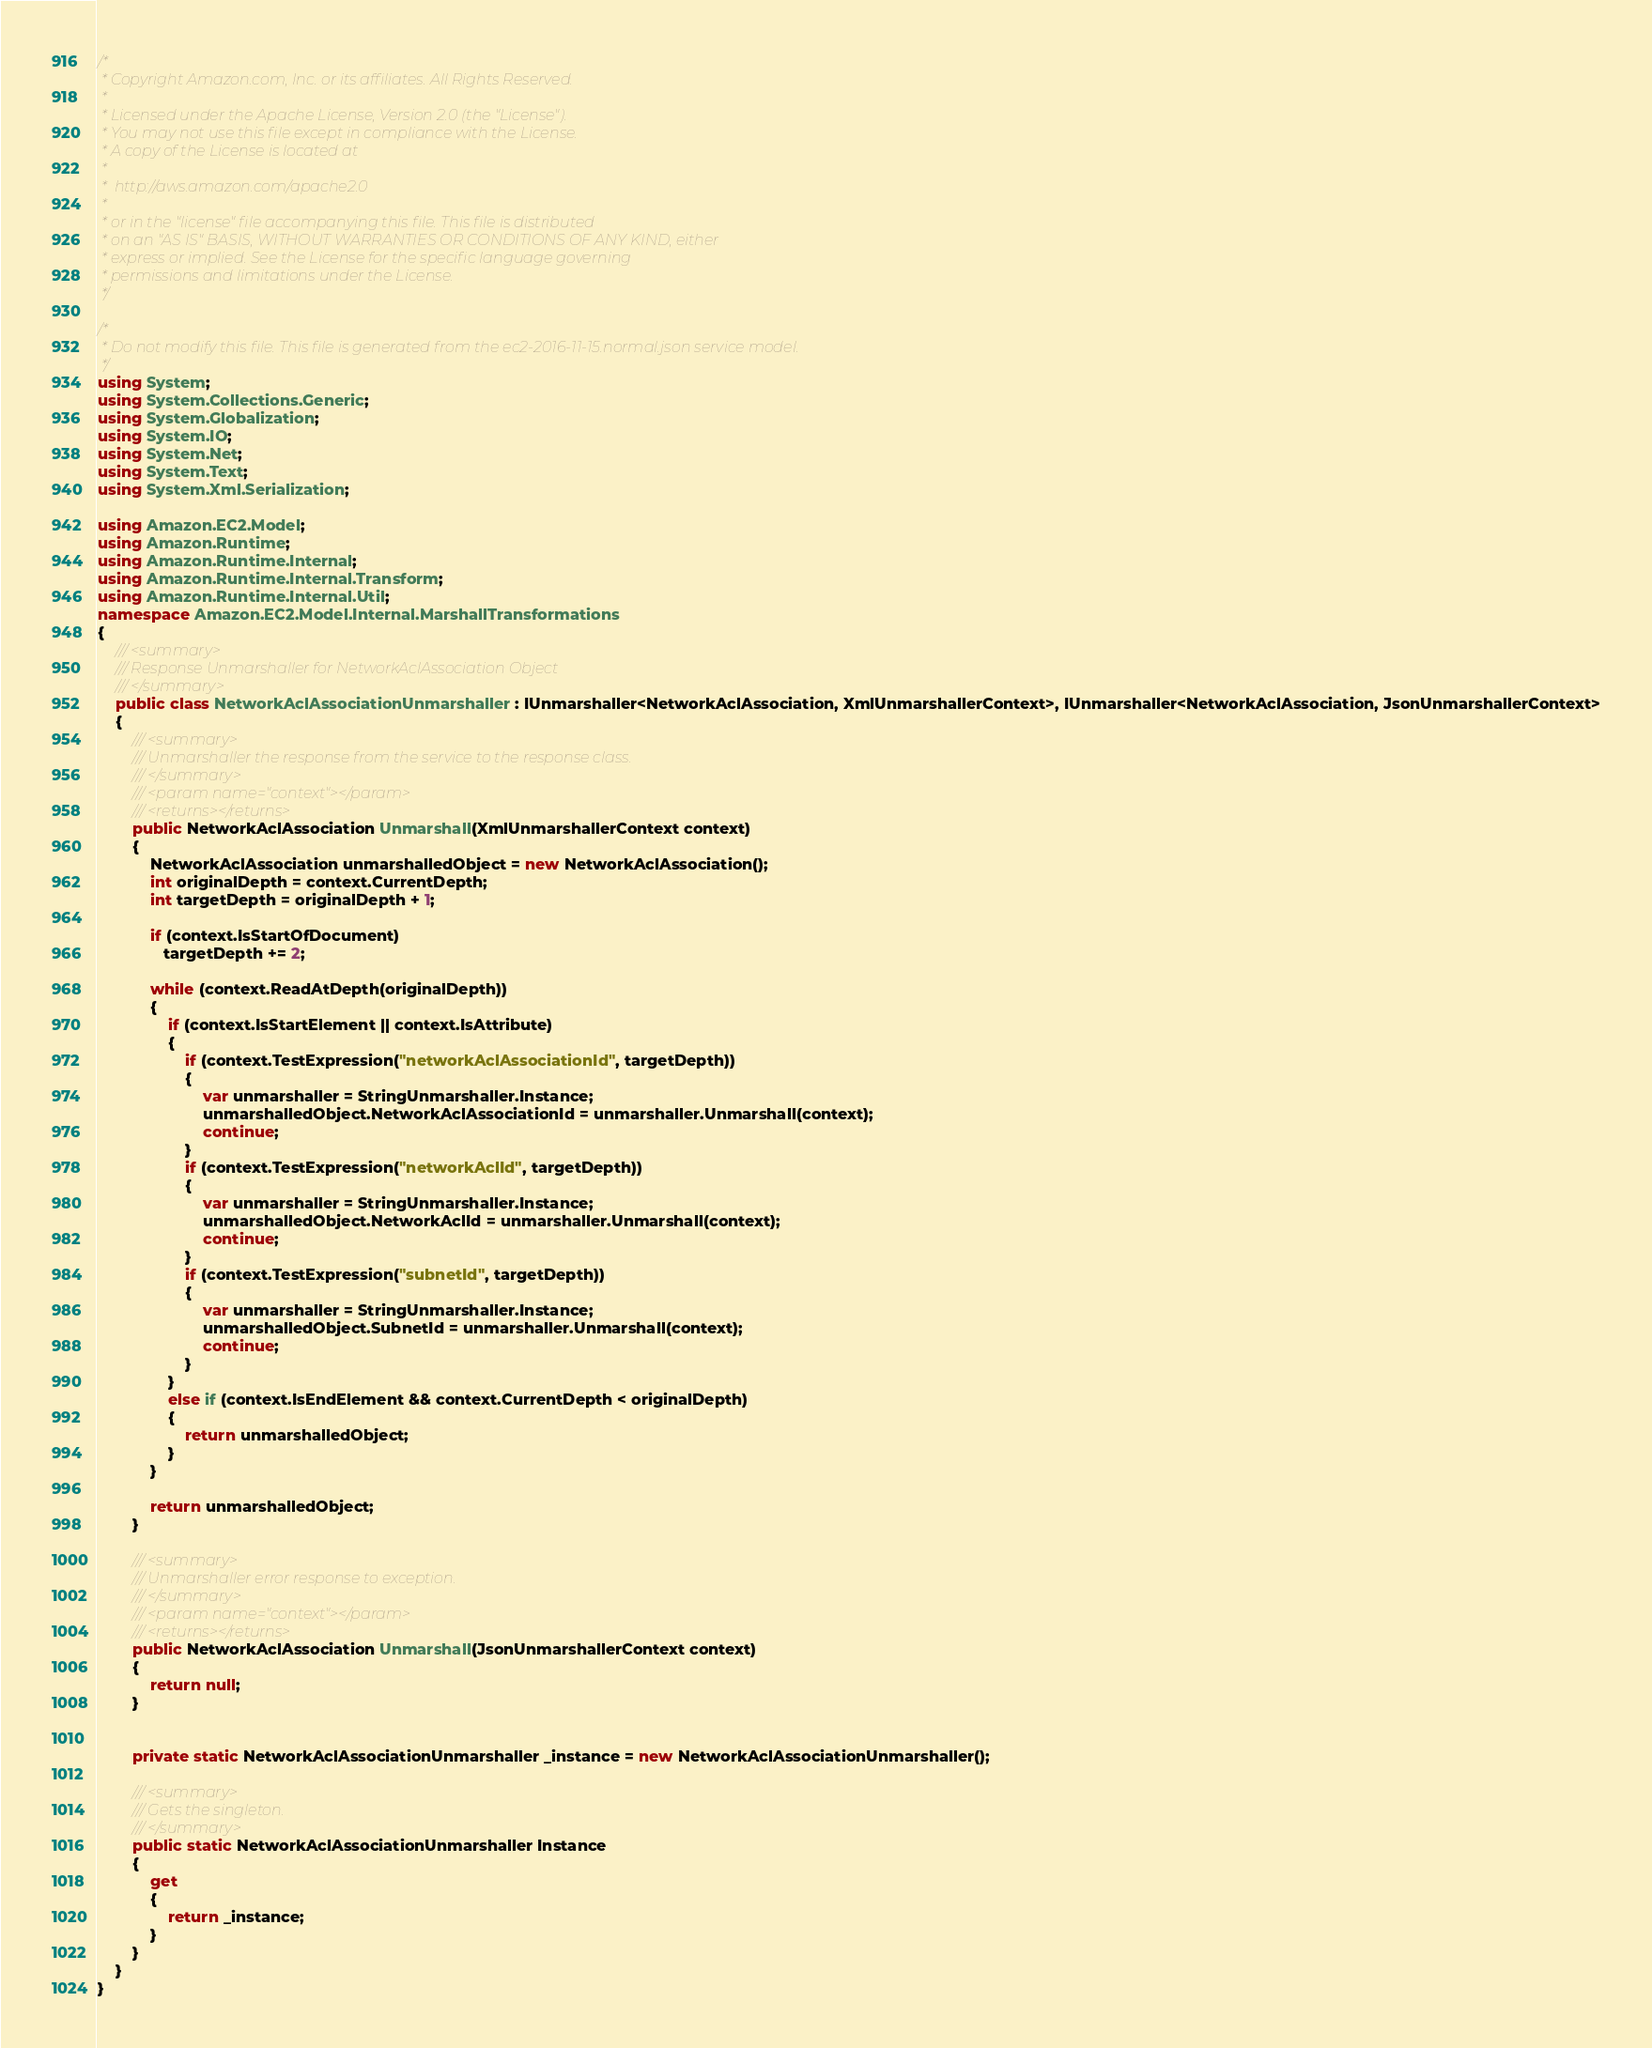Convert code to text. <code><loc_0><loc_0><loc_500><loc_500><_C#_>/*
 * Copyright Amazon.com, Inc. or its affiliates. All Rights Reserved.
 * 
 * Licensed under the Apache License, Version 2.0 (the "License").
 * You may not use this file except in compliance with the License.
 * A copy of the License is located at
 * 
 *  http://aws.amazon.com/apache2.0
 * 
 * or in the "license" file accompanying this file. This file is distributed
 * on an "AS IS" BASIS, WITHOUT WARRANTIES OR CONDITIONS OF ANY KIND, either
 * express or implied. See the License for the specific language governing
 * permissions and limitations under the License.
 */

/*
 * Do not modify this file. This file is generated from the ec2-2016-11-15.normal.json service model.
 */
using System;
using System.Collections.Generic;
using System.Globalization;
using System.IO;
using System.Net;
using System.Text;
using System.Xml.Serialization;

using Amazon.EC2.Model;
using Amazon.Runtime;
using Amazon.Runtime.Internal;
using Amazon.Runtime.Internal.Transform;
using Amazon.Runtime.Internal.Util;
namespace Amazon.EC2.Model.Internal.MarshallTransformations
{
    /// <summary>
    /// Response Unmarshaller for NetworkAclAssociation Object
    /// </summary>  
    public class NetworkAclAssociationUnmarshaller : IUnmarshaller<NetworkAclAssociation, XmlUnmarshallerContext>, IUnmarshaller<NetworkAclAssociation, JsonUnmarshallerContext>
    {
        /// <summary>
        /// Unmarshaller the response from the service to the response class.
        /// </summary>  
        /// <param name="context"></param>
        /// <returns></returns>
        public NetworkAclAssociation Unmarshall(XmlUnmarshallerContext context)
        {
            NetworkAclAssociation unmarshalledObject = new NetworkAclAssociation();
            int originalDepth = context.CurrentDepth;
            int targetDepth = originalDepth + 1;
            
            if (context.IsStartOfDocument) 
               targetDepth += 2;
            
            while (context.ReadAtDepth(originalDepth))
            {
                if (context.IsStartElement || context.IsAttribute)
                {
                    if (context.TestExpression("networkAclAssociationId", targetDepth))
                    {
                        var unmarshaller = StringUnmarshaller.Instance;
                        unmarshalledObject.NetworkAclAssociationId = unmarshaller.Unmarshall(context);
                        continue;
                    }
                    if (context.TestExpression("networkAclId", targetDepth))
                    {
                        var unmarshaller = StringUnmarshaller.Instance;
                        unmarshalledObject.NetworkAclId = unmarshaller.Unmarshall(context);
                        continue;
                    }
                    if (context.TestExpression("subnetId", targetDepth))
                    {
                        var unmarshaller = StringUnmarshaller.Instance;
                        unmarshalledObject.SubnetId = unmarshaller.Unmarshall(context);
                        continue;
                    }
                }
                else if (context.IsEndElement && context.CurrentDepth < originalDepth)
                {
                    return unmarshalledObject;
                }
            }

            return unmarshalledObject;
        }

        /// <summary>
        /// Unmarshaller error response to exception.
        /// </summary>  
        /// <param name="context"></param>
        /// <returns></returns>
        public NetworkAclAssociation Unmarshall(JsonUnmarshallerContext context)
        {
            return null;
        }


        private static NetworkAclAssociationUnmarshaller _instance = new NetworkAclAssociationUnmarshaller();        

        /// <summary>
        /// Gets the singleton.
        /// </summary>  
        public static NetworkAclAssociationUnmarshaller Instance
        {
            get
            {
                return _instance;
            }
        }
    }
}</code> 